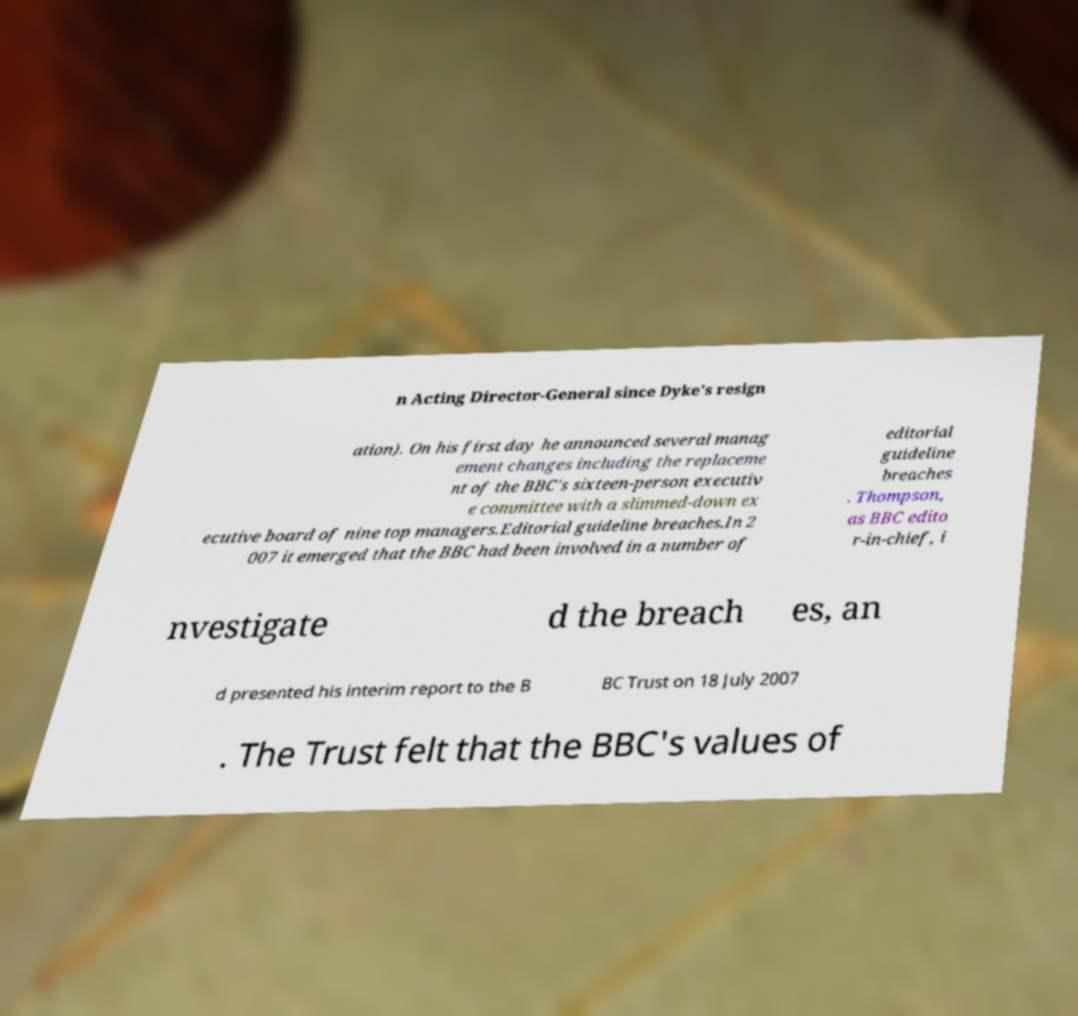Please read and relay the text visible in this image. What does it say? n Acting Director-General since Dyke's resign ation). On his first day he announced several manag ement changes including the replaceme nt of the BBC's sixteen-person executiv e committee with a slimmed-down ex ecutive board of nine top managers.Editorial guideline breaches.In 2 007 it emerged that the BBC had been involved in a number of editorial guideline breaches . Thompson, as BBC edito r-in-chief, i nvestigate d the breach es, an d presented his interim report to the B BC Trust on 18 July 2007 . The Trust felt that the BBC's values of 